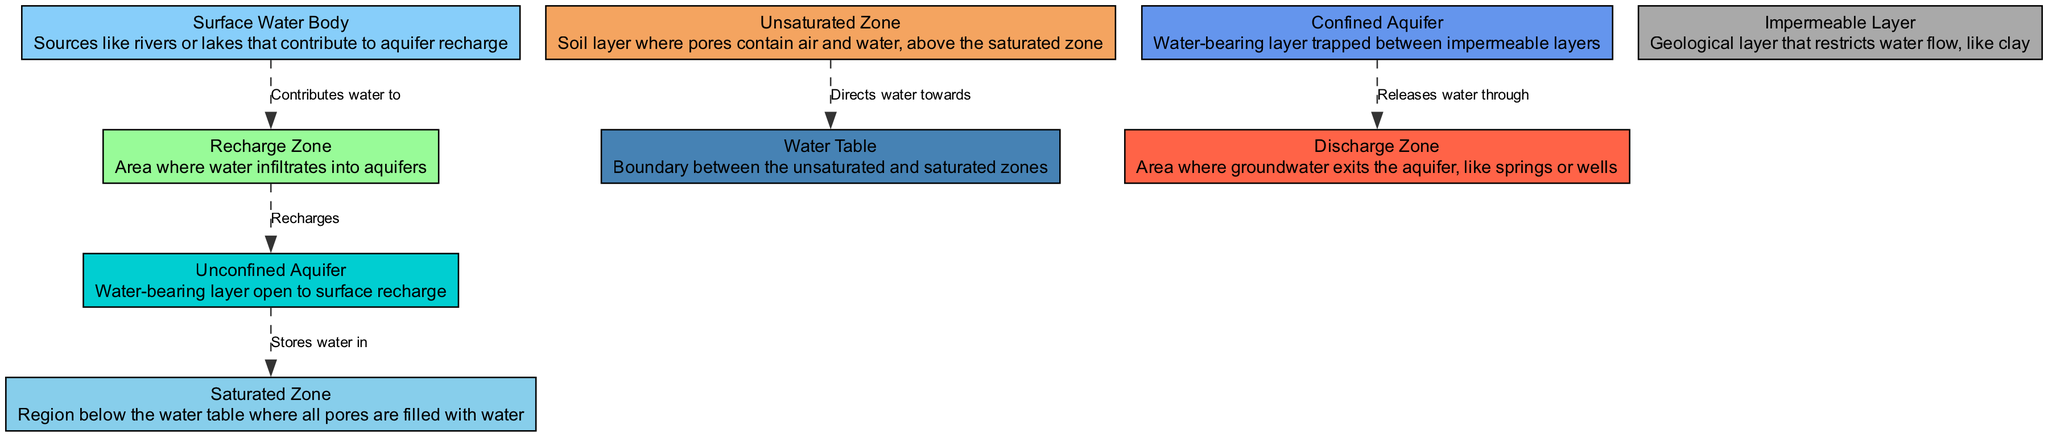What is the relationship between the Surface Water Body and the Recharge Zone? The diagram indicates that the Surface Water Body contributes water to the Recharge Zone. This is shown by a directed edge connecting these two nodes, labeled "Contributes water to."
Answer: Contributes water to How many nodes are represented in the diagram? By counting the distinct node labels in the data provided, we find there are ten unique nodes: Surface Water Body, Unsaturated Zone, Saturated Zone, Water Table, Confined Aquifer, Unconfined Aquifer, Recharge Zone, Discharge Zone, and Impermeable Layer.
Answer: 10 What does the Unsaturated Zone direct water towards? According to the diagram, the Unsaturated Zone directs water towards the Water Table. This is evidenced by an edge connecting these two nodes, indicating the flow direction.
Answer: Water Table What stores water in the Saturated Zone? The diagram indicates that the Unconfined Aquifer stores water in the Saturated Zone. This relationship is depicted with an edge labeled "Stores water in."
Answer: Unconfined Aquifer Which zone releases water through the Discharge Zone? The Confined Aquifer releases water through the Discharge Zone, as shown by the directed edge with the label "Releases water through." This means that the Confined Aquifer is the source of water exiting the system.
Answer: Confined Aquifer What type of aquifer is open to surface recharge? From the diagram, the Unconfined Aquifer is identified as the type that is open to surface recharge. This is specified by the label and position in relation to other nodes.
Answer: Unconfined Aquifer Which geological layer restricts water flow? The Impermeable Layer is represented in the diagram as the geological layer that restricts water flow. This is defined within its node and is critical in understanding groundwater movement.
Answer: Impermeable Layer How does water infiltrate into aquifers according to the diagram? Water infiltrates into aquifers via the Recharge Zone. The connection between these two nodes labeled "Recharges" indicates that this is the process through which the aquifer receives additional water supply.
Answer: Recharge Zone What zone is described as the area where groundwater exits the aquifer? The Discharge Zone is indicated in the diagram as the area where groundwater exits the aquifer, which is evidenced by its definition and the connections drawn to other components in the diagram.
Answer: Discharge Zone 